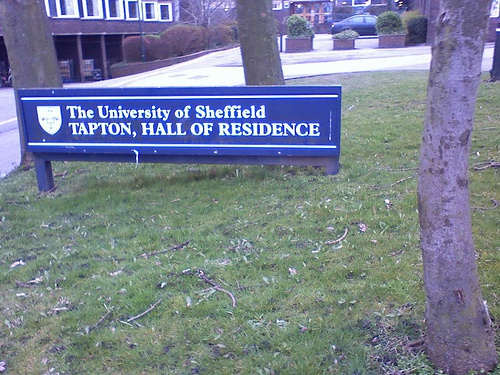Describe the objects in this image and their specific colors. I can see potted plant in gray tones, potted plant in gray and darkgray tones, and car in gray, blue, lightblue, and lavender tones in this image. 